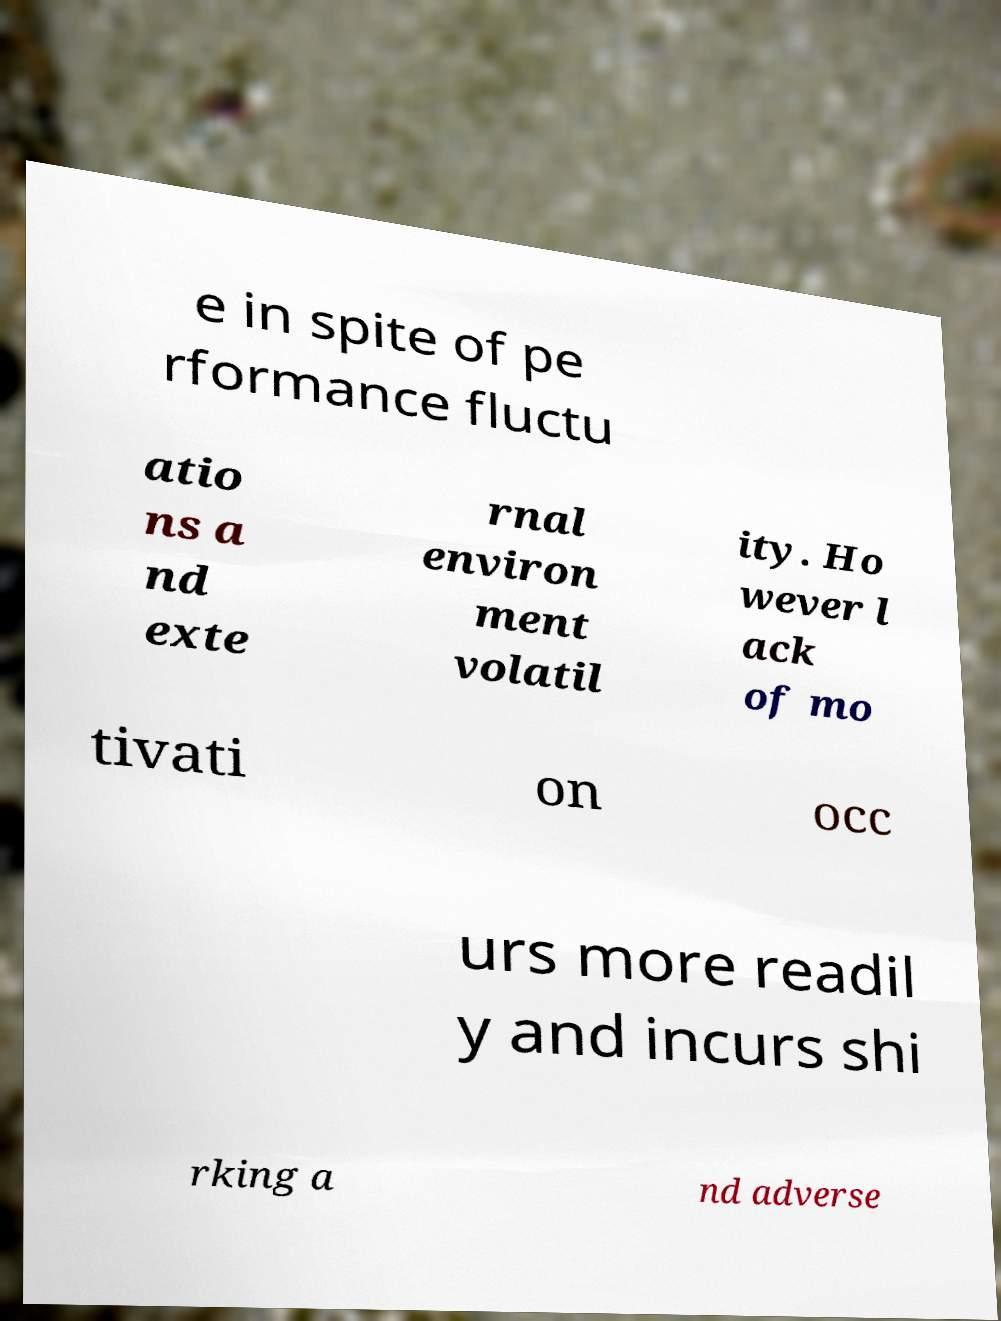Can you accurately transcribe the text from the provided image for me? e in spite of pe rformance fluctu atio ns a nd exte rnal environ ment volatil ity. Ho wever l ack of mo tivati on occ urs more readil y and incurs shi rking a nd adverse 